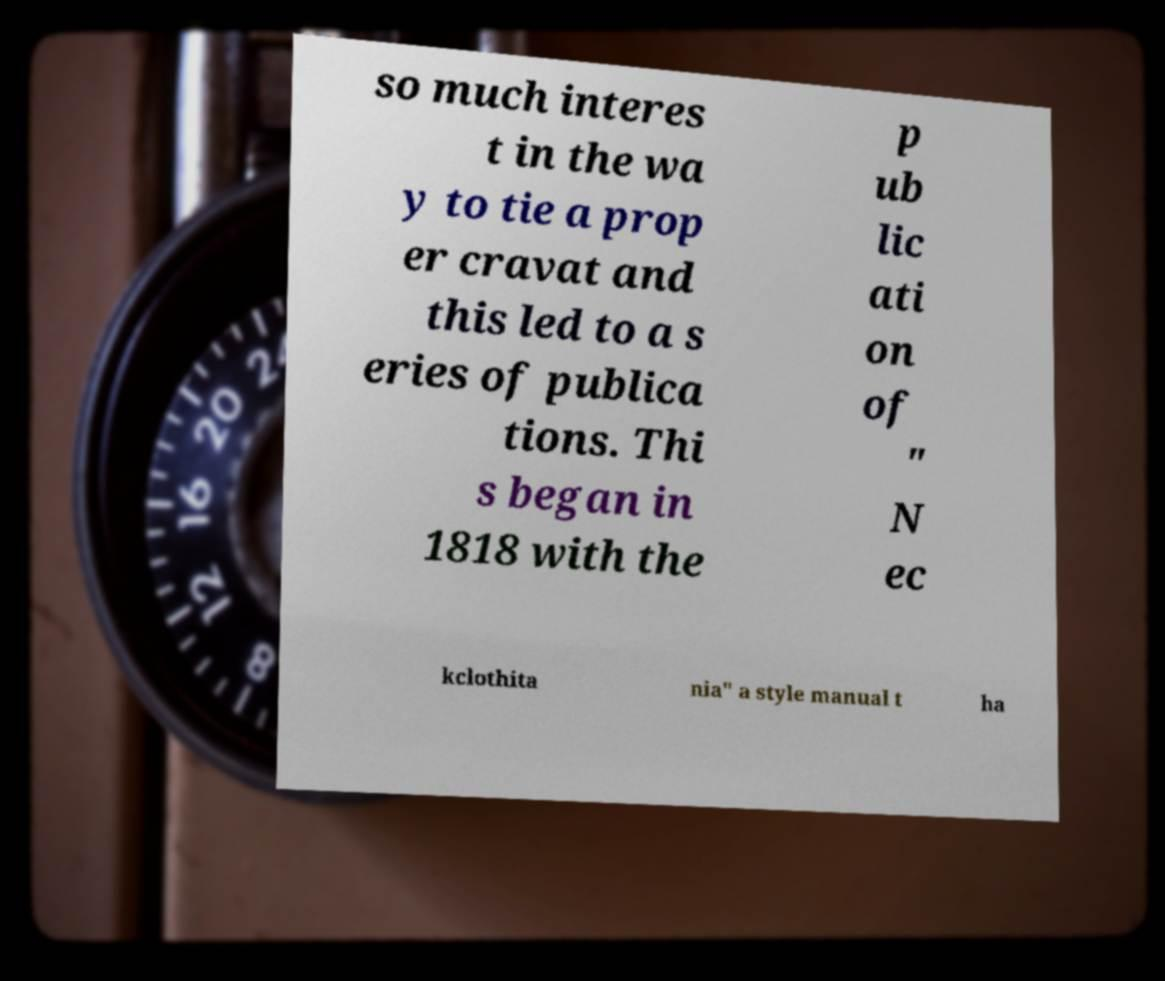For documentation purposes, I need the text within this image transcribed. Could you provide that? so much interes t in the wa y to tie a prop er cravat and this led to a s eries of publica tions. Thi s began in 1818 with the p ub lic ati on of " N ec kclothita nia" a style manual t ha 